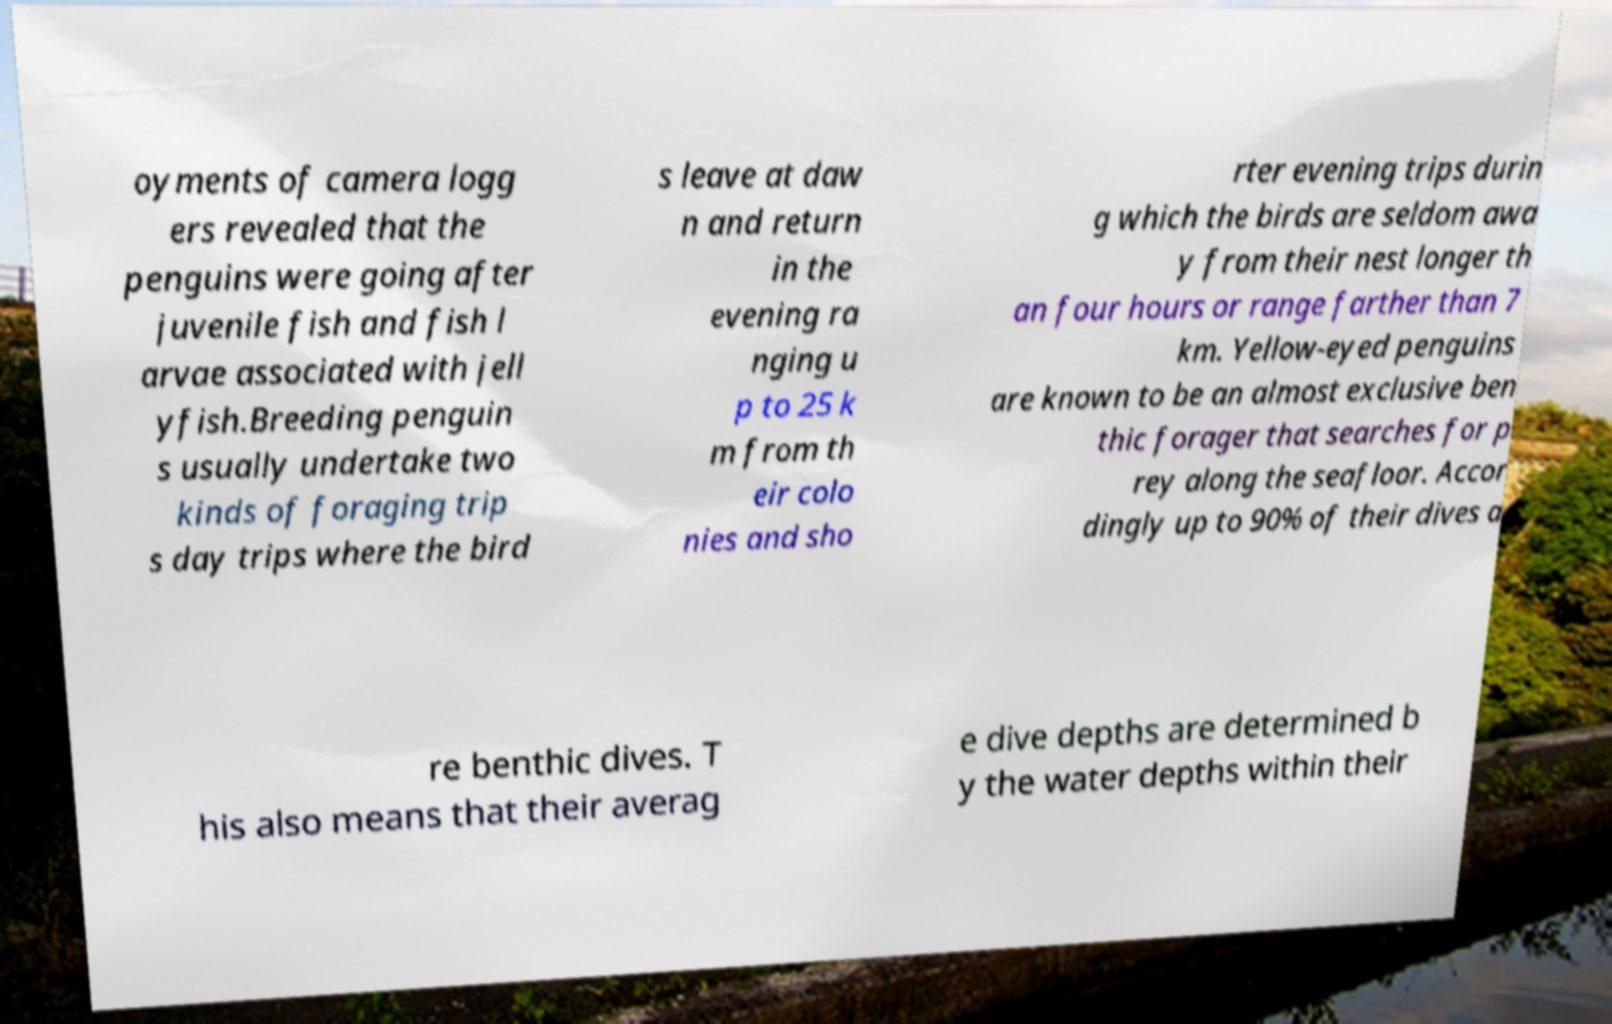Could you extract and type out the text from this image? oyments of camera logg ers revealed that the penguins were going after juvenile fish and fish l arvae associated with jell yfish.Breeding penguin s usually undertake two kinds of foraging trip s day trips where the bird s leave at daw n and return in the evening ra nging u p to 25 k m from th eir colo nies and sho rter evening trips durin g which the birds are seldom awa y from their nest longer th an four hours or range farther than 7 km. Yellow-eyed penguins are known to be an almost exclusive ben thic forager that searches for p rey along the seafloor. Accor dingly up to 90% of their dives a re benthic dives. T his also means that their averag e dive depths are determined b y the water depths within their 